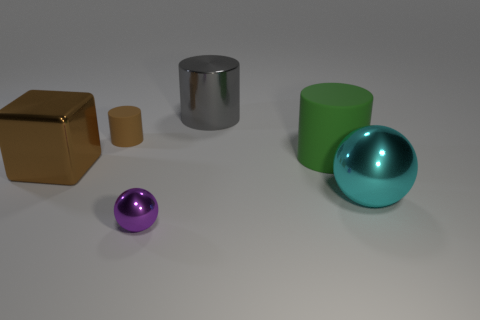Add 2 gray metallic spheres. How many objects exist? 8 Subtract all blocks. How many objects are left? 5 Subtract all tiny cylinders. Subtract all large green matte cylinders. How many objects are left? 4 Add 1 small cylinders. How many small cylinders are left? 2 Add 4 cyan matte spheres. How many cyan matte spheres exist? 4 Subtract 1 gray cylinders. How many objects are left? 5 